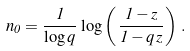<formula> <loc_0><loc_0><loc_500><loc_500>n _ { 0 } = \frac { 1 } { \log q } \, \log \left ( \, \frac { 1 - z } { 1 - q \, z } \right ) \, .</formula> 